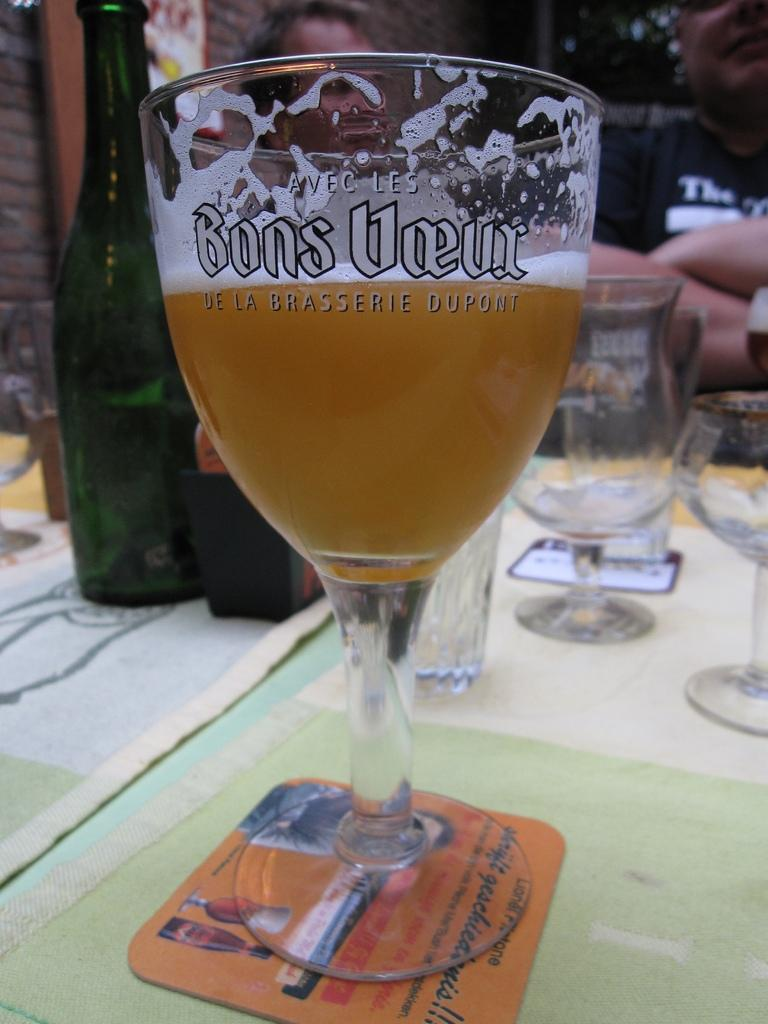<image>
Offer a succinct explanation of the picture presented. A fancy ale glass holds a label of De La Brasserie Dupont. 